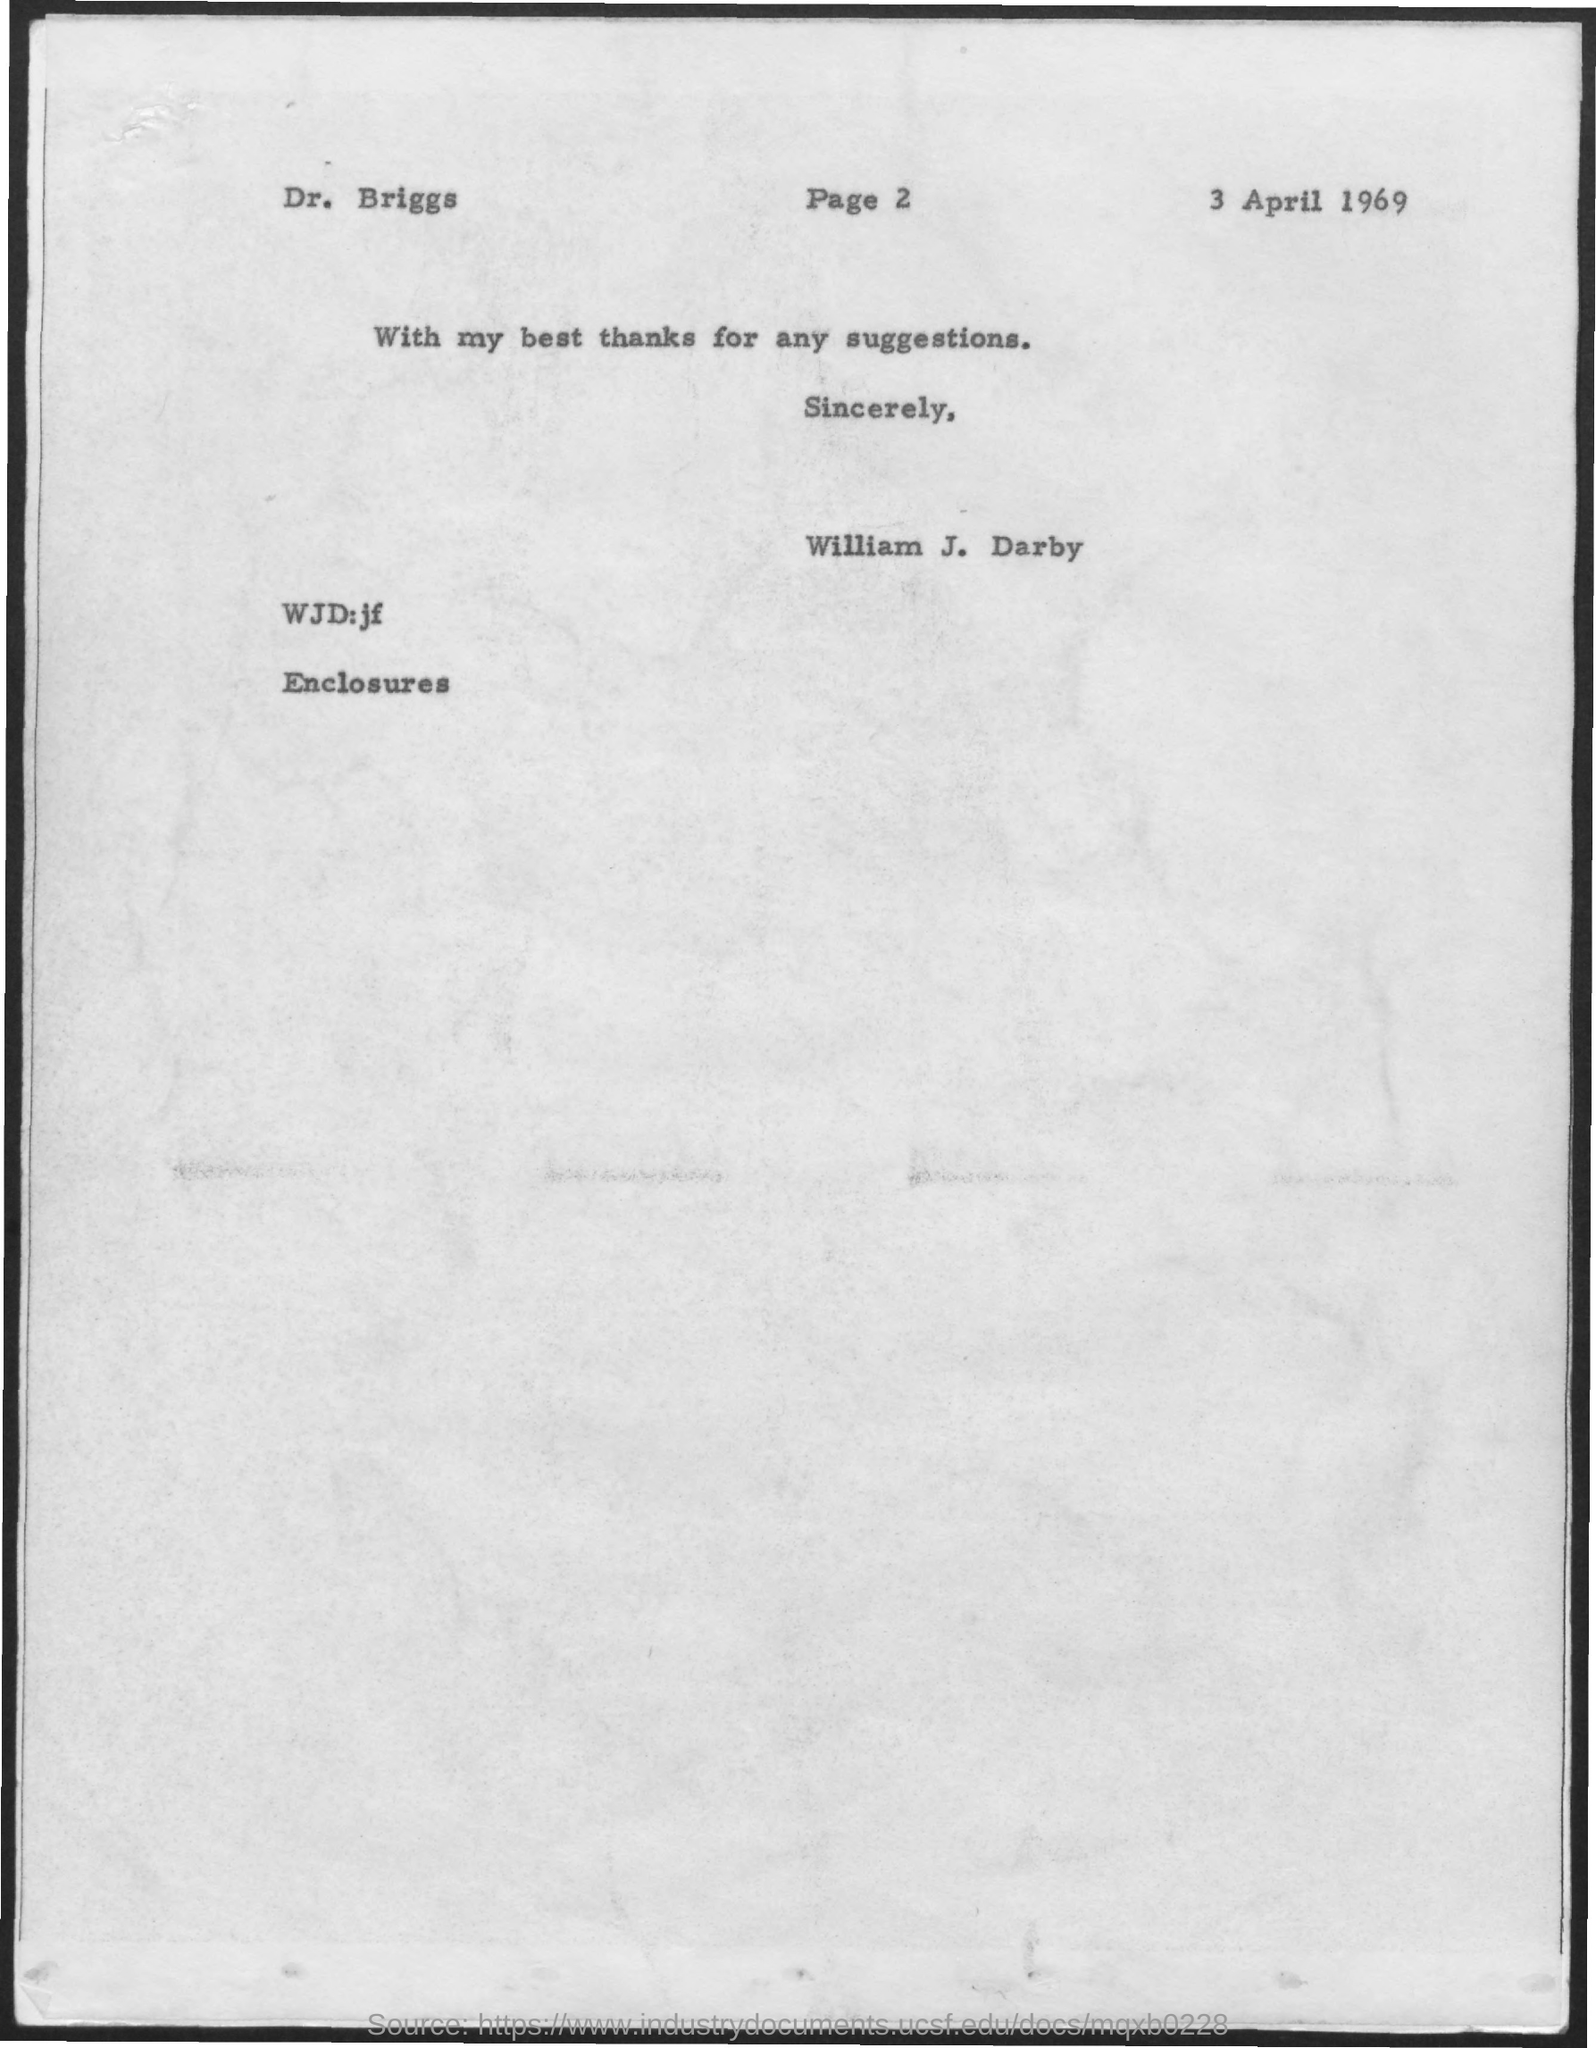What is the date mentioned ?
Your response must be concise. 3 April 1969. 